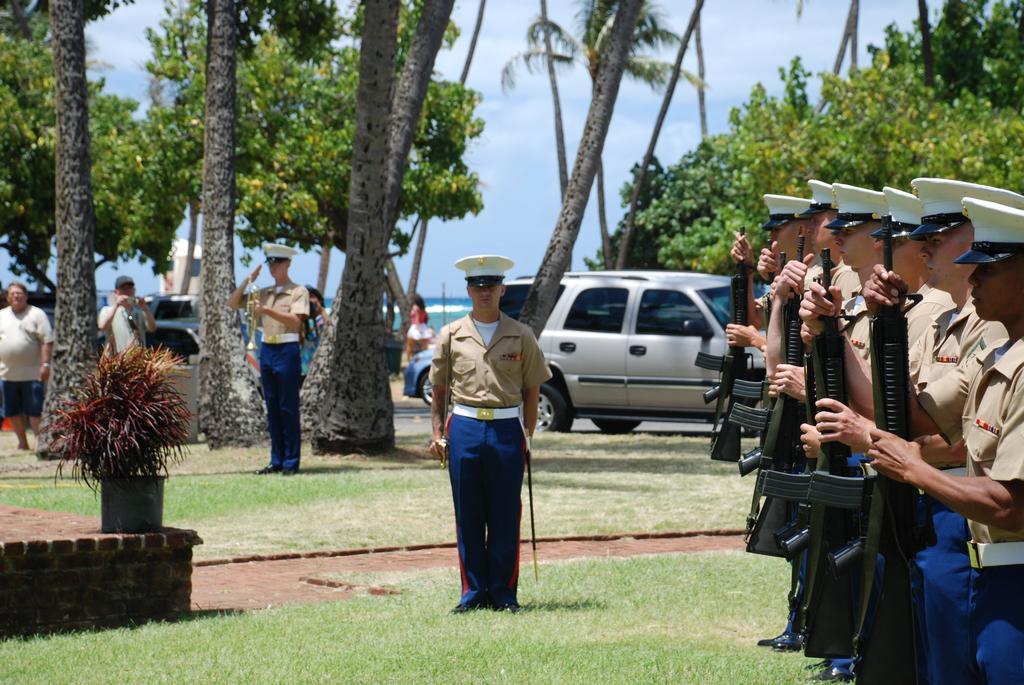Please provide a concise description of this image. In this we can see few people standing on the ground, some of them are holding guns, a person is holding a musical instrument, there is a potted plant on the wall, in the background there are few vehicles, trees and the sky. 